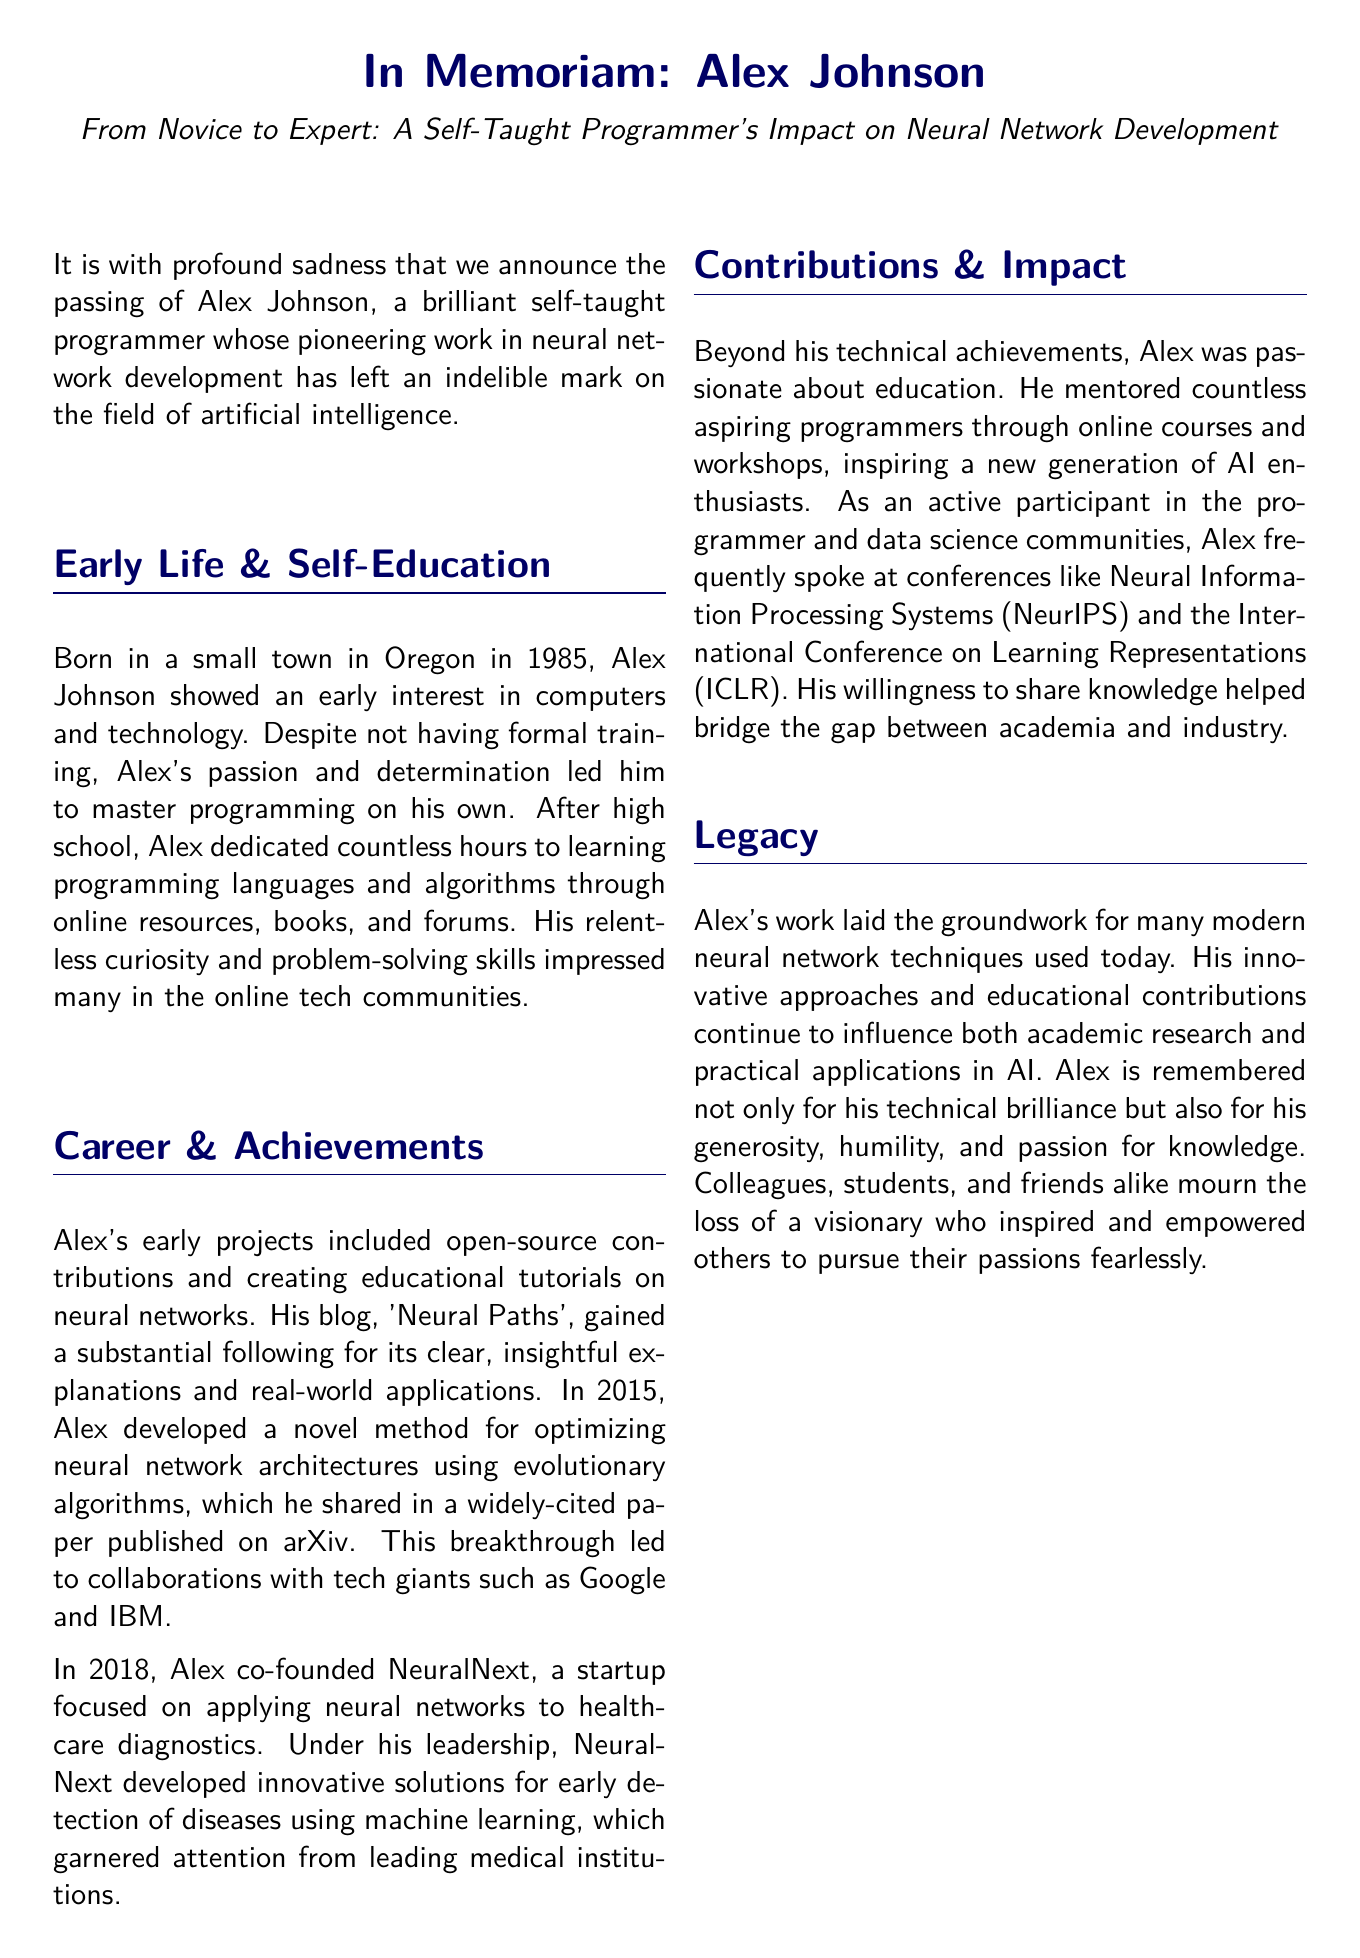What was Alex Johnson's year of birth? The document states that Alex Johnson was born in 1985.
Answer: 1985 What was the name of Alex's blog? The blog created by Alex that gained a substantial following is referred to as 'Neural Paths'.
Answer: Neural Paths In what year did Alex co-found NeuralNext? According to the document, Alex co-founded NeuralNext in 2018.
Answer: 2018 Which companies did Alex collaborate with after his breakthrough? The document mentions collaborations with tech giants such as Google and IBM.
Answer: Google and IBM What type of events did Alex frequently speak at? The document states that Alex frequently spoke at conferences like NeurIPS and ICLR.
Answer: conferences What two qualities is Alex remembered for besides his technical brilliance? The document highlights Alex's generosity and humility as additional qualities he is remembered for.
Answer: generosity, humility What impact did Alex have on aspiring programmers? According to the document, Alex mentored countless aspiring programmers and inspired a new generation of AI enthusiasts.
Answer: mentored and inspired Where will the memorial service for Alex be held? The document specifies that the memorial service will be held at the Oregon Science and Technology Museum.
Answer: Oregon Science and Technology Museum How many children did Alex have? The document states that Alex is survived by his two children.
Answer: two 